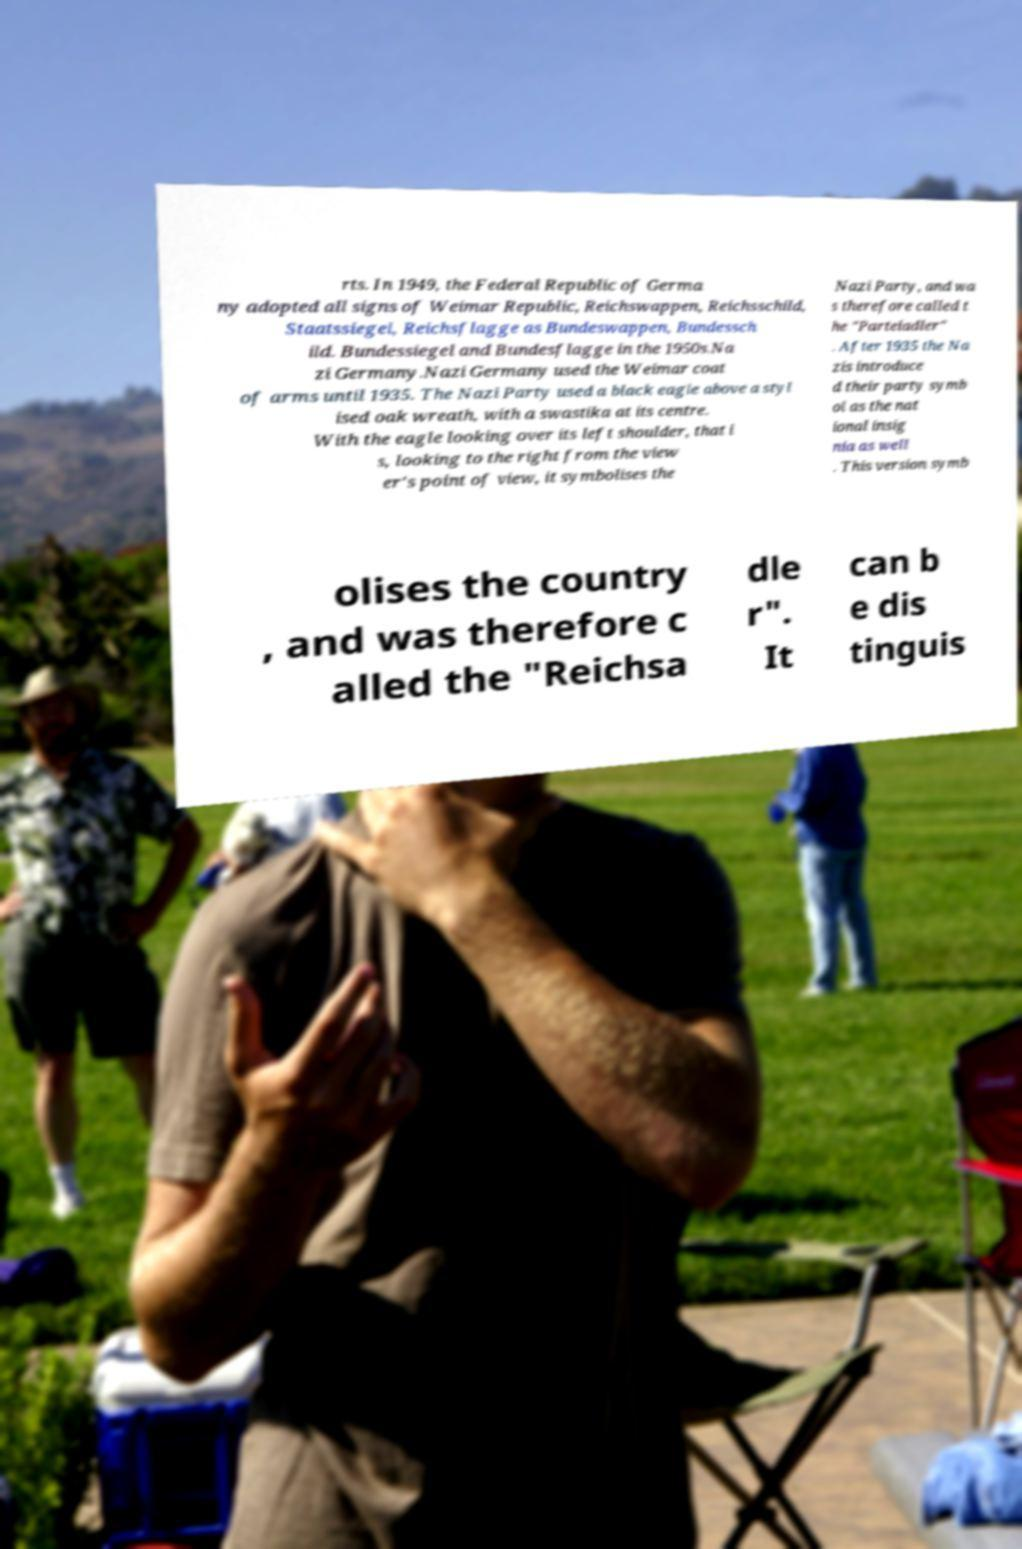Can you read and provide the text displayed in the image?This photo seems to have some interesting text. Can you extract and type it out for me? rts. In 1949, the Federal Republic of Germa ny adopted all signs of Weimar Republic, Reichswappen, Reichsschild, Staatssiegel, Reichsflagge as Bundeswappen, Bundessch ild. Bundessiegel and Bundesflagge in the 1950s.Na zi Germany.Nazi Germany used the Weimar coat of arms until 1935. The Nazi Party used a black eagle above a styl ised oak wreath, with a swastika at its centre. With the eagle looking over its left shoulder, that i s, looking to the right from the view er's point of view, it symbolises the Nazi Party, and wa s therefore called t he "Parteiadler" . After 1935 the Na zis introduce d their party symb ol as the nat ional insig nia as well . This version symb olises the country , and was therefore c alled the "Reichsa dle r". It can b e dis tinguis 